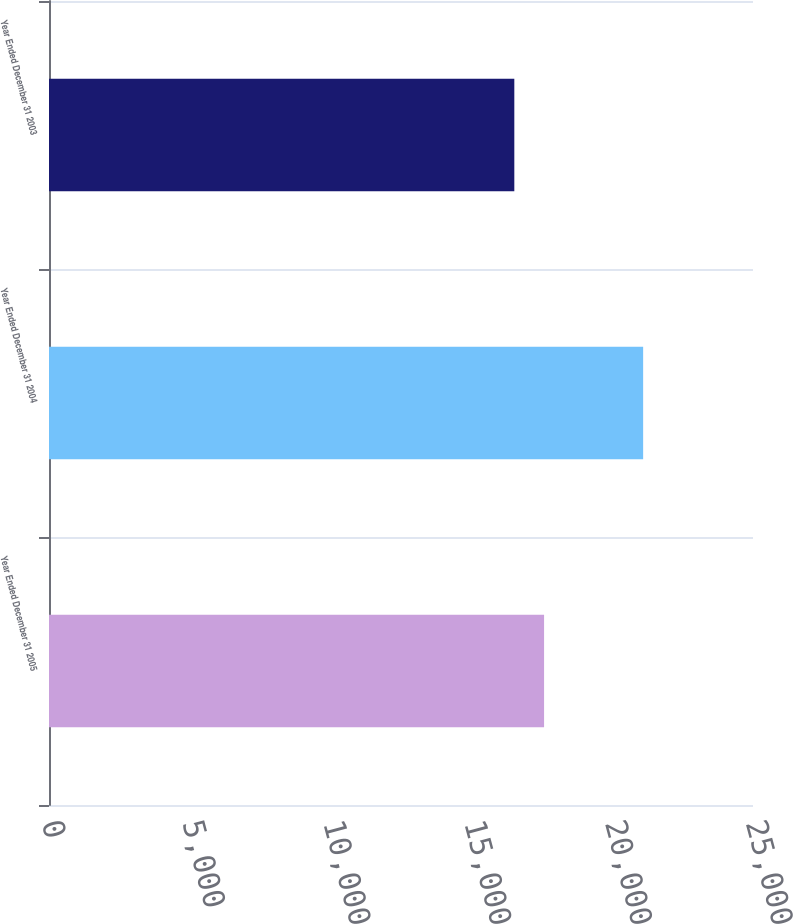<chart> <loc_0><loc_0><loc_500><loc_500><bar_chart><fcel>Year Ended December 31 2005<fcel>Year Ended December 31 2004<fcel>Year Ended December 31 2003<nl><fcel>17581<fcel>21099<fcel>16524<nl></chart> 